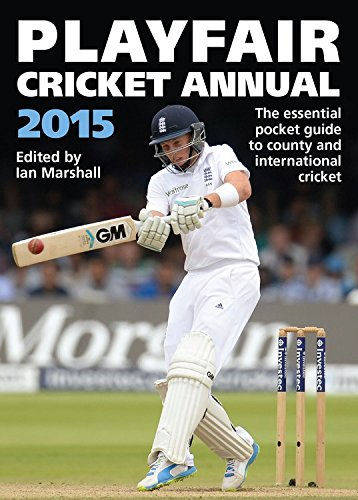Who might find this book useful? Cricket players, coaches, analysts, and fans would find this book incredibly useful for its comprehensive statistics and coverage of both county and international cricket matches during the year. 